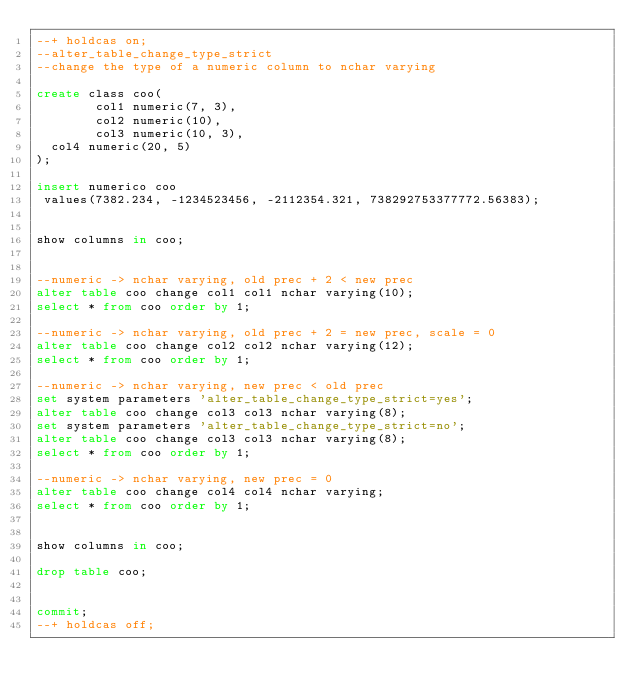Convert code to text. <code><loc_0><loc_0><loc_500><loc_500><_SQL_>--+ holdcas on;
--alter_table_change_type_strict
--change the type of a numeric column to nchar varying

create class coo(
        col1 numeric(7, 3),
        col2 numeric(10),
        col3 numeric(10, 3),
	col4 numeric(20, 5)
);

insert numerico coo
 values(7382.234, -1234523456, -2112354.321, 738292753377772.56383);


show columns in coo;


--numeric -> nchar varying, old prec + 2 < new prec
alter table coo change col1 col1 nchar varying(10);
select * from coo order by 1;

--numeric -> nchar varying, old prec + 2 = new prec, scale = 0
alter table coo change col2 col2 nchar varying(12);
select * from coo order by 1;

--numeric -> nchar varying, new prec < old prec
set system parameters 'alter_table_change_type_strict=yes';
alter table coo change col3 col3 nchar varying(8);
set system parameters 'alter_table_change_type_strict=no';
alter table coo change col3 col3 nchar varying(8);
select * from coo order by 1;

--numeric -> nchar varying, new prec = 0
alter table coo change col4 col4 nchar varying;
select * from coo order by 1;


show columns in coo;

drop table coo;


commit;
--+ holdcas off;
</code> 